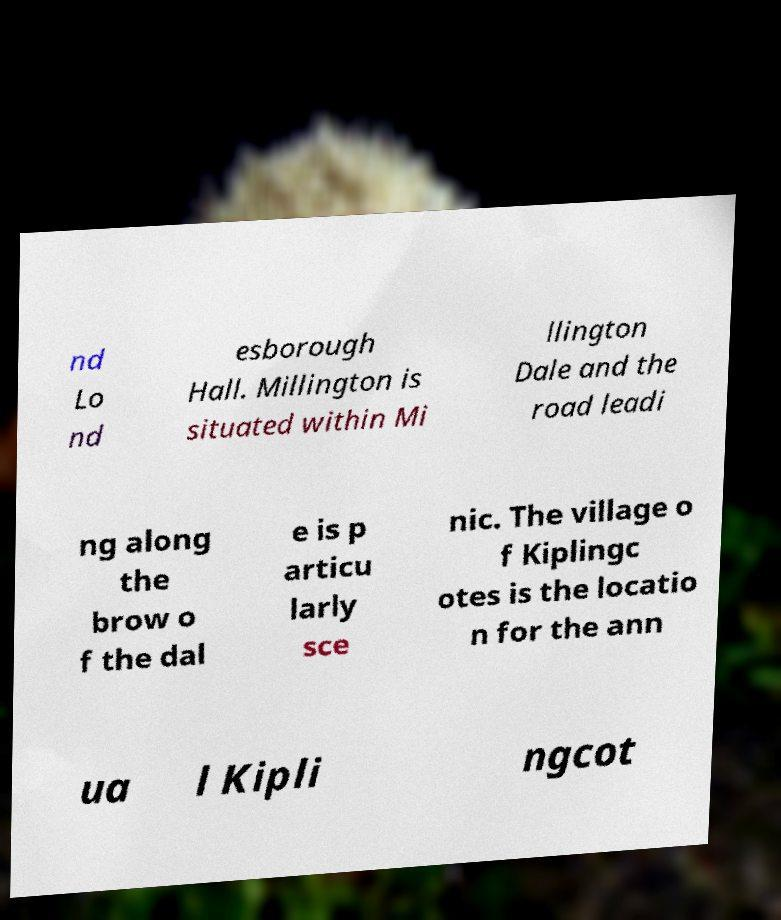Could you assist in decoding the text presented in this image and type it out clearly? nd Lo nd esborough Hall. Millington is situated within Mi llington Dale and the road leadi ng along the brow o f the dal e is p articu larly sce nic. The village o f Kiplingc otes is the locatio n for the ann ua l Kipli ngcot 